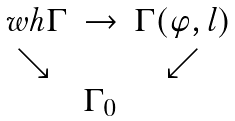<formula> <loc_0><loc_0><loc_500><loc_500>\begin{matrix} \ w h \Gamma & \to & \Gamma ( \varphi , l ) \\ \searrow & & \swarrow \\ & \Gamma _ { 0 } & \end{matrix}</formula> 